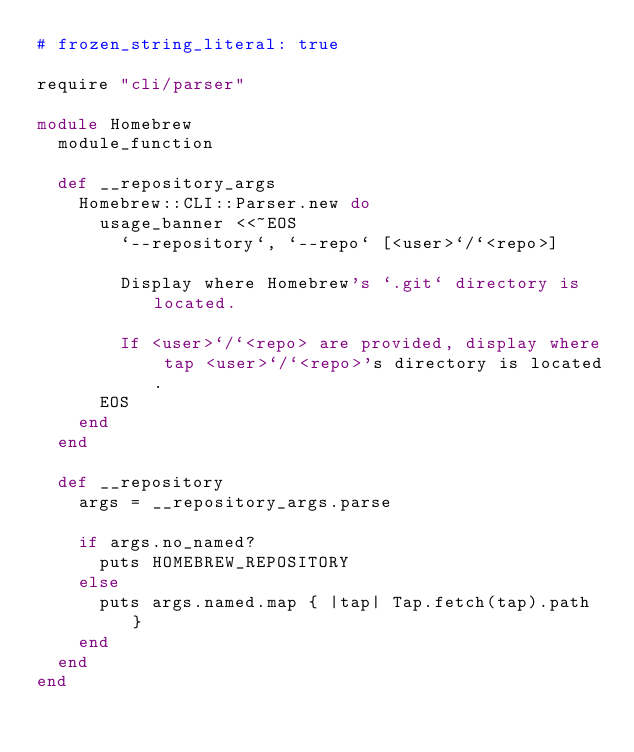Convert code to text. <code><loc_0><loc_0><loc_500><loc_500><_Ruby_># frozen_string_literal: true

require "cli/parser"

module Homebrew
  module_function

  def __repository_args
    Homebrew::CLI::Parser.new do
      usage_banner <<~EOS
        `--repository`, `--repo` [<user>`/`<repo>]

        Display where Homebrew's `.git` directory is located.

        If <user>`/`<repo> are provided, display where tap <user>`/`<repo>'s directory is located.
      EOS
    end
  end

  def __repository
    args = __repository_args.parse

    if args.no_named?
      puts HOMEBREW_REPOSITORY
    else
      puts args.named.map { |tap| Tap.fetch(tap).path }
    end
  end
end
</code> 